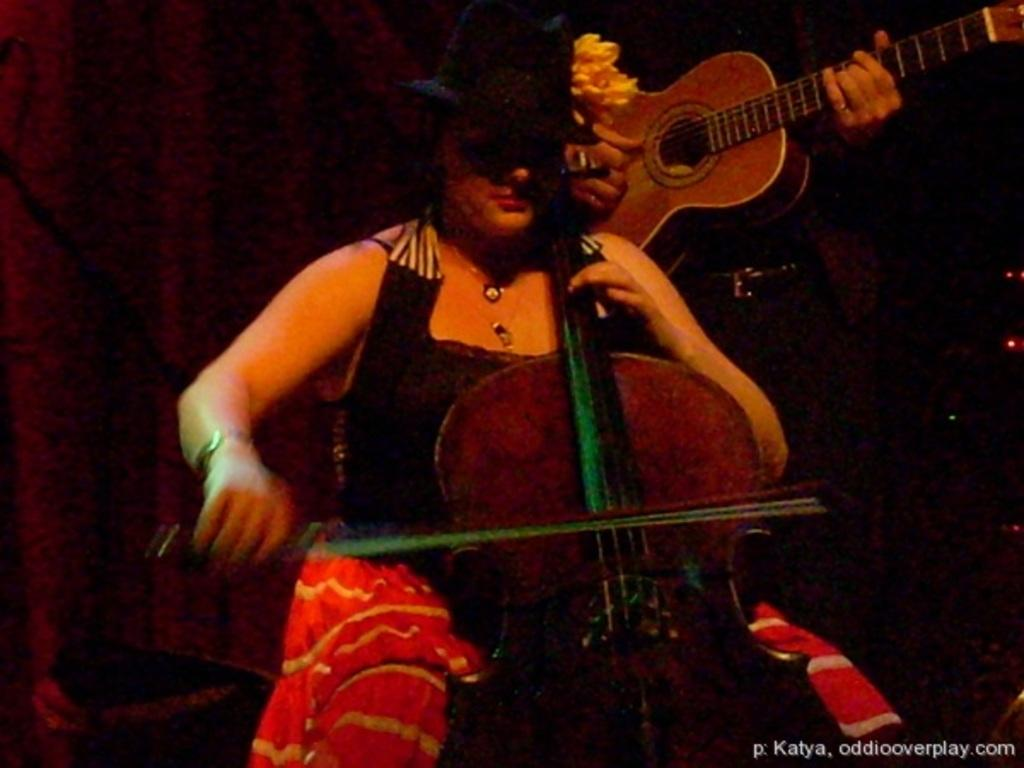What is the main subject of the image? The main subject of the image is a woman. What is the woman doing in the image? The woman is playing a guitar. What type of accessory is the woman wearing in the image? The woman is wearing a hat. What type of circle is being used for the operation in the image? There is no circle or operation present in the image; it features a woman playing a guitar and wearing a hat. 